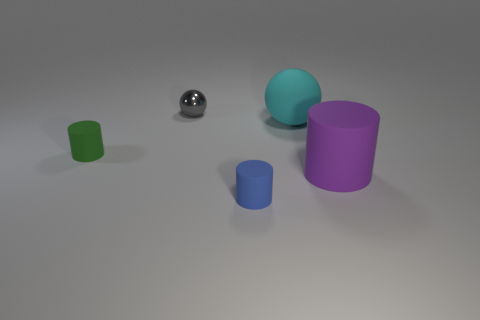How many small red matte objects are there?
Give a very brief answer. 0. What is the shape of the small gray metal object?
Keep it short and to the point. Sphere. What number of blue matte cylinders are the same size as the green rubber object?
Give a very brief answer. 1. Is the small blue object the same shape as the purple thing?
Offer a very short reply. Yes. There is a small rubber object that is on the right side of the cylinder behind the large purple rubber object; what color is it?
Make the answer very short. Blue. There is a rubber thing that is right of the blue thing and to the left of the large purple rubber cylinder; how big is it?
Offer a terse response. Large. Are there any other things that have the same color as the big cylinder?
Offer a very short reply. No. What is the shape of the large cyan thing that is the same material as the blue cylinder?
Offer a very short reply. Sphere. Do the tiny blue matte object and the small matte object to the left of the metallic object have the same shape?
Your answer should be very brief. Yes. The cylinder that is behind the cylinder to the right of the blue rubber cylinder is made of what material?
Make the answer very short. Rubber. 